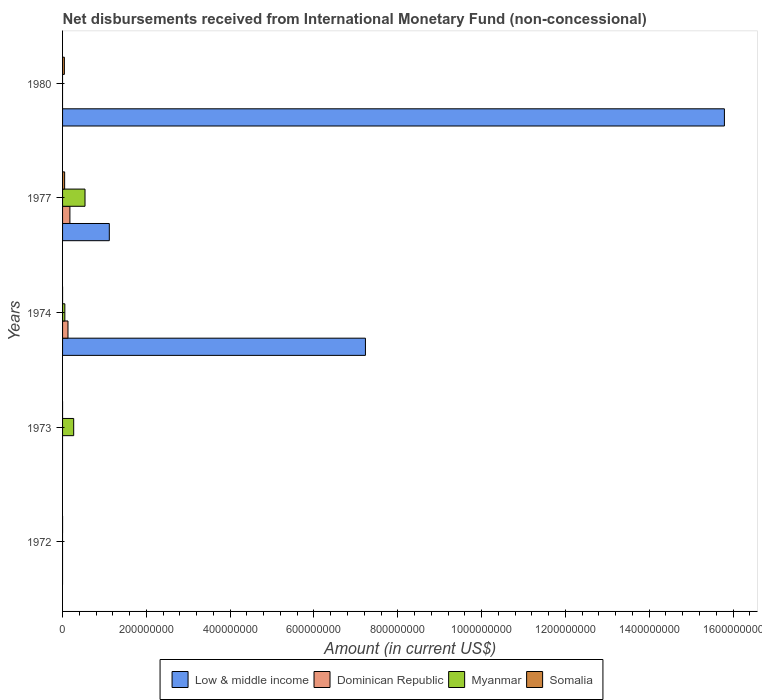How many different coloured bars are there?
Offer a terse response. 4. Are the number of bars on each tick of the Y-axis equal?
Keep it short and to the point. No. What is the label of the 4th group of bars from the top?
Provide a short and direct response. 1973. What is the amount of disbursements received from International Monetary Fund in Low & middle income in 1972?
Provide a succinct answer. 0. Across all years, what is the maximum amount of disbursements received from International Monetary Fund in Somalia?
Provide a short and direct response. 4.94e+06. Across all years, what is the minimum amount of disbursements received from International Monetary Fund in Dominican Republic?
Keep it short and to the point. 0. What is the total amount of disbursements received from International Monetary Fund in Myanmar in the graph?
Ensure brevity in your answer.  8.56e+07. What is the difference between the amount of disbursements received from International Monetary Fund in Low & middle income in 1974 and that in 1980?
Give a very brief answer. -8.57e+08. What is the difference between the amount of disbursements received from International Monetary Fund in Myanmar in 1980 and the amount of disbursements received from International Monetary Fund in Low & middle income in 1977?
Your answer should be compact. -1.12e+08. What is the average amount of disbursements received from International Monetary Fund in Low & middle income per year?
Your response must be concise. 4.83e+08. In the year 1974, what is the difference between the amount of disbursements received from International Monetary Fund in Dominican Republic and amount of disbursements received from International Monetary Fund in Myanmar?
Keep it short and to the point. 7.48e+06. In how many years, is the amount of disbursements received from International Monetary Fund in Dominican Republic greater than 1520000000 US$?
Offer a very short reply. 0. What is the ratio of the amount of disbursements received from International Monetary Fund in Dominican Republic in 1974 to that in 1977?
Offer a terse response. 0.74. What is the difference between the highest and the second highest amount of disbursements received from International Monetary Fund in Low & middle income?
Provide a short and direct response. 8.57e+08. What is the difference between the highest and the lowest amount of disbursements received from International Monetary Fund in Somalia?
Provide a succinct answer. 4.94e+06. In how many years, is the amount of disbursements received from International Monetary Fund in Myanmar greater than the average amount of disbursements received from International Monetary Fund in Myanmar taken over all years?
Give a very brief answer. 2. Is it the case that in every year, the sum of the amount of disbursements received from International Monetary Fund in Somalia and amount of disbursements received from International Monetary Fund in Myanmar is greater than the sum of amount of disbursements received from International Monetary Fund in Low & middle income and amount of disbursements received from International Monetary Fund in Dominican Republic?
Provide a short and direct response. No. How many bars are there?
Offer a very short reply. 10. Are all the bars in the graph horizontal?
Offer a terse response. Yes. How many years are there in the graph?
Your response must be concise. 5. Does the graph contain any zero values?
Your answer should be compact. Yes. Does the graph contain grids?
Your response must be concise. No. How many legend labels are there?
Provide a succinct answer. 4. How are the legend labels stacked?
Provide a short and direct response. Horizontal. What is the title of the graph?
Keep it short and to the point. Net disbursements received from International Monetary Fund (non-concessional). What is the Amount (in current US$) in Dominican Republic in 1972?
Offer a terse response. 0. What is the Amount (in current US$) in Myanmar in 1972?
Give a very brief answer. 0. What is the Amount (in current US$) of Somalia in 1972?
Your answer should be very brief. 0. What is the Amount (in current US$) in Low & middle income in 1973?
Provide a succinct answer. 0. What is the Amount (in current US$) of Myanmar in 1973?
Make the answer very short. 2.65e+07. What is the Amount (in current US$) in Somalia in 1973?
Offer a terse response. 0. What is the Amount (in current US$) in Low & middle income in 1974?
Keep it short and to the point. 7.23e+08. What is the Amount (in current US$) of Dominican Republic in 1974?
Ensure brevity in your answer.  1.29e+07. What is the Amount (in current US$) of Myanmar in 1974?
Make the answer very short. 5.45e+06. What is the Amount (in current US$) of Low & middle income in 1977?
Provide a succinct answer. 1.12e+08. What is the Amount (in current US$) in Dominican Republic in 1977?
Ensure brevity in your answer.  1.75e+07. What is the Amount (in current US$) in Myanmar in 1977?
Ensure brevity in your answer.  5.36e+07. What is the Amount (in current US$) in Somalia in 1977?
Your response must be concise. 4.94e+06. What is the Amount (in current US$) in Low & middle income in 1980?
Ensure brevity in your answer.  1.58e+09. What is the Amount (in current US$) in Dominican Republic in 1980?
Keep it short and to the point. 0. What is the Amount (in current US$) in Myanmar in 1980?
Give a very brief answer. 0. What is the Amount (in current US$) in Somalia in 1980?
Provide a succinct answer. 4.30e+06. Across all years, what is the maximum Amount (in current US$) of Low & middle income?
Give a very brief answer. 1.58e+09. Across all years, what is the maximum Amount (in current US$) in Dominican Republic?
Offer a very short reply. 1.75e+07. Across all years, what is the maximum Amount (in current US$) of Myanmar?
Your answer should be compact. 5.36e+07. Across all years, what is the maximum Amount (in current US$) in Somalia?
Offer a terse response. 4.94e+06. Across all years, what is the minimum Amount (in current US$) of Low & middle income?
Ensure brevity in your answer.  0. Across all years, what is the minimum Amount (in current US$) in Myanmar?
Your answer should be compact. 0. What is the total Amount (in current US$) of Low & middle income in the graph?
Ensure brevity in your answer.  2.41e+09. What is the total Amount (in current US$) in Dominican Republic in the graph?
Ensure brevity in your answer.  3.04e+07. What is the total Amount (in current US$) of Myanmar in the graph?
Provide a succinct answer. 8.56e+07. What is the total Amount (in current US$) of Somalia in the graph?
Offer a terse response. 9.24e+06. What is the difference between the Amount (in current US$) of Myanmar in 1973 and that in 1974?
Make the answer very short. 2.11e+07. What is the difference between the Amount (in current US$) in Myanmar in 1973 and that in 1977?
Provide a succinct answer. -2.70e+07. What is the difference between the Amount (in current US$) in Low & middle income in 1974 and that in 1977?
Ensure brevity in your answer.  6.11e+08. What is the difference between the Amount (in current US$) in Dominican Republic in 1974 and that in 1977?
Ensure brevity in your answer.  -4.58e+06. What is the difference between the Amount (in current US$) in Myanmar in 1974 and that in 1977?
Your answer should be very brief. -4.81e+07. What is the difference between the Amount (in current US$) in Low & middle income in 1974 and that in 1980?
Ensure brevity in your answer.  -8.57e+08. What is the difference between the Amount (in current US$) of Low & middle income in 1977 and that in 1980?
Your response must be concise. -1.47e+09. What is the difference between the Amount (in current US$) in Somalia in 1977 and that in 1980?
Offer a terse response. 6.39e+05. What is the difference between the Amount (in current US$) in Myanmar in 1973 and the Amount (in current US$) in Somalia in 1977?
Give a very brief answer. 2.16e+07. What is the difference between the Amount (in current US$) in Myanmar in 1973 and the Amount (in current US$) in Somalia in 1980?
Give a very brief answer. 2.22e+07. What is the difference between the Amount (in current US$) in Low & middle income in 1974 and the Amount (in current US$) in Dominican Republic in 1977?
Offer a very short reply. 7.05e+08. What is the difference between the Amount (in current US$) of Low & middle income in 1974 and the Amount (in current US$) of Myanmar in 1977?
Ensure brevity in your answer.  6.69e+08. What is the difference between the Amount (in current US$) of Low & middle income in 1974 and the Amount (in current US$) of Somalia in 1977?
Your response must be concise. 7.18e+08. What is the difference between the Amount (in current US$) in Dominican Republic in 1974 and the Amount (in current US$) in Myanmar in 1977?
Offer a terse response. -4.06e+07. What is the difference between the Amount (in current US$) in Dominican Republic in 1974 and the Amount (in current US$) in Somalia in 1977?
Keep it short and to the point. 7.99e+06. What is the difference between the Amount (in current US$) in Myanmar in 1974 and the Amount (in current US$) in Somalia in 1977?
Your answer should be very brief. 5.15e+05. What is the difference between the Amount (in current US$) in Low & middle income in 1974 and the Amount (in current US$) in Somalia in 1980?
Keep it short and to the point. 7.18e+08. What is the difference between the Amount (in current US$) of Dominican Republic in 1974 and the Amount (in current US$) of Somalia in 1980?
Keep it short and to the point. 8.63e+06. What is the difference between the Amount (in current US$) of Myanmar in 1974 and the Amount (in current US$) of Somalia in 1980?
Offer a terse response. 1.15e+06. What is the difference between the Amount (in current US$) of Low & middle income in 1977 and the Amount (in current US$) of Somalia in 1980?
Your answer should be very brief. 1.07e+08. What is the difference between the Amount (in current US$) in Dominican Republic in 1977 and the Amount (in current US$) in Somalia in 1980?
Ensure brevity in your answer.  1.32e+07. What is the difference between the Amount (in current US$) in Myanmar in 1977 and the Amount (in current US$) in Somalia in 1980?
Your answer should be very brief. 4.93e+07. What is the average Amount (in current US$) in Low & middle income per year?
Offer a terse response. 4.83e+08. What is the average Amount (in current US$) of Dominican Republic per year?
Give a very brief answer. 6.09e+06. What is the average Amount (in current US$) in Myanmar per year?
Offer a terse response. 1.71e+07. What is the average Amount (in current US$) in Somalia per year?
Give a very brief answer. 1.85e+06. In the year 1974, what is the difference between the Amount (in current US$) in Low & middle income and Amount (in current US$) in Dominican Republic?
Offer a terse response. 7.10e+08. In the year 1974, what is the difference between the Amount (in current US$) of Low & middle income and Amount (in current US$) of Myanmar?
Provide a succinct answer. 7.17e+08. In the year 1974, what is the difference between the Amount (in current US$) in Dominican Republic and Amount (in current US$) in Myanmar?
Give a very brief answer. 7.48e+06. In the year 1977, what is the difference between the Amount (in current US$) in Low & middle income and Amount (in current US$) in Dominican Republic?
Keep it short and to the point. 9.40e+07. In the year 1977, what is the difference between the Amount (in current US$) in Low & middle income and Amount (in current US$) in Myanmar?
Offer a terse response. 5.80e+07. In the year 1977, what is the difference between the Amount (in current US$) in Low & middle income and Amount (in current US$) in Somalia?
Ensure brevity in your answer.  1.07e+08. In the year 1977, what is the difference between the Amount (in current US$) of Dominican Republic and Amount (in current US$) of Myanmar?
Your response must be concise. -3.61e+07. In the year 1977, what is the difference between the Amount (in current US$) of Dominican Republic and Amount (in current US$) of Somalia?
Keep it short and to the point. 1.26e+07. In the year 1977, what is the difference between the Amount (in current US$) of Myanmar and Amount (in current US$) of Somalia?
Ensure brevity in your answer.  4.86e+07. In the year 1980, what is the difference between the Amount (in current US$) in Low & middle income and Amount (in current US$) in Somalia?
Provide a short and direct response. 1.58e+09. What is the ratio of the Amount (in current US$) in Myanmar in 1973 to that in 1974?
Provide a short and direct response. 4.87. What is the ratio of the Amount (in current US$) of Myanmar in 1973 to that in 1977?
Make the answer very short. 0.5. What is the ratio of the Amount (in current US$) of Low & middle income in 1974 to that in 1977?
Offer a terse response. 6.48. What is the ratio of the Amount (in current US$) of Dominican Republic in 1974 to that in 1977?
Your answer should be very brief. 0.74. What is the ratio of the Amount (in current US$) of Myanmar in 1974 to that in 1977?
Your answer should be very brief. 0.1. What is the ratio of the Amount (in current US$) in Low & middle income in 1974 to that in 1980?
Offer a very short reply. 0.46. What is the ratio of the Amount (in current US$) of Low & middle income in 1977 to that in 1980?
Keep it short and to the point. 0.07. What is the ratio of the Amount (in current US$) of Somalia in 1977 to that in 1980?
Make the answer very short. 1.15. What is the difference between the highest and the second highest Amount (in current US$) in Low & middle income?
Offer a very short reply. 8.57e+08. What is the difference between the highest and the second highest Amount (in current US$) in Myanmar?
Your answer should be compact. 2.70e+07. What is the difference between the highest and the lowest Amount (in current US$) of Low & middle income?
Make the answer very short. 1.58e+09. What is the difference between the highest and the lowest Amount (in current US$) of Dominican Republic?
Provide a succinct answer. 1.75e+07. What is the difference between the highest and the lowest Amount (in current US$) in Myanmar?
Keep it short and to the point. 5.36e+07. What is the difference between the highest and the lowest Amount (in current US$) in Somalia?
Your answer should be very brief. 4.94e+06. 